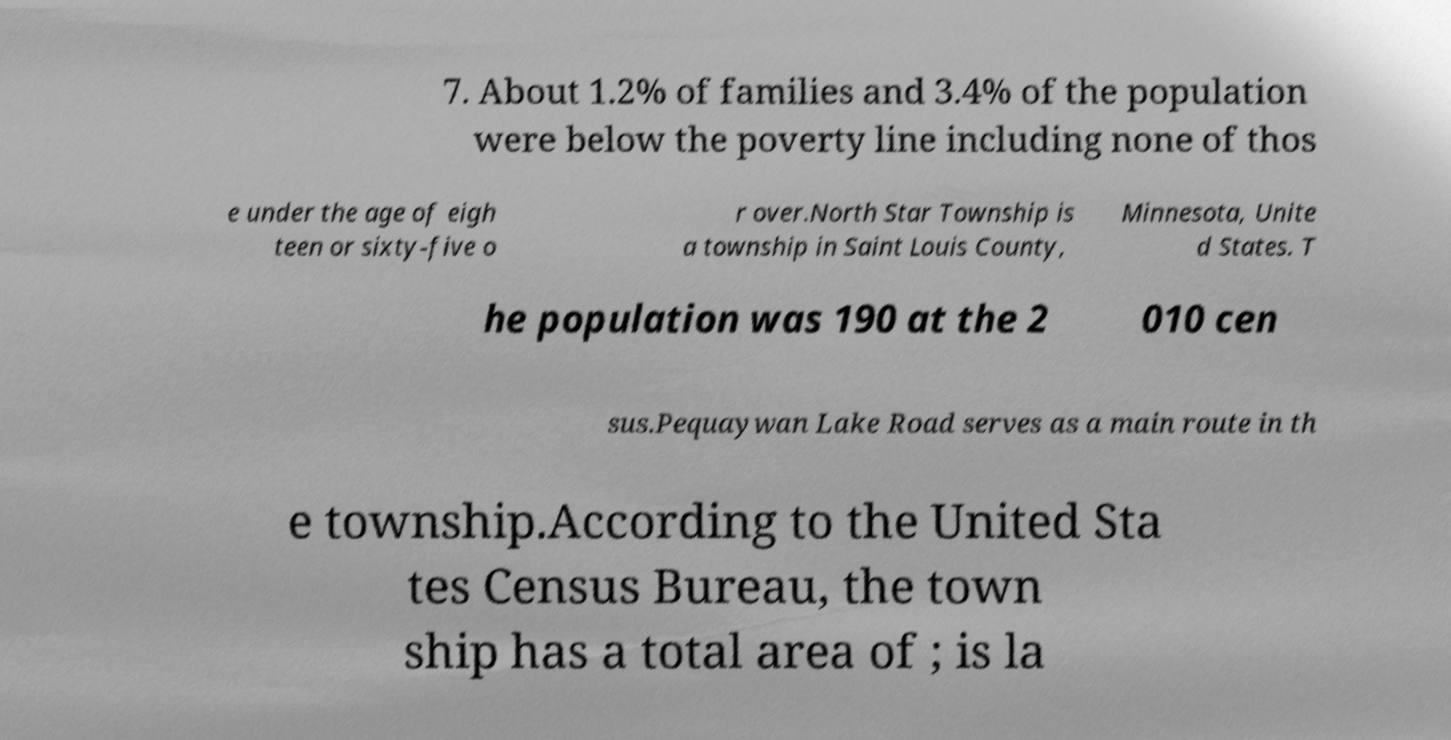Could you extract and type out the text from this image? 7. About 1.2% of families and 3.4% of the population were below the poverty line including none of thos e under the age of eigh teen or sixty-five o r over.North Star Township is a township in Saint Louis County, Minnesota, Unite d States. T he population was 190 at the 2 010 cen sus.Pequaywan Lake Road serves as a main route in th e township.According to the United Sta tes Census Bureau, the town ship has a total area of ; is la 